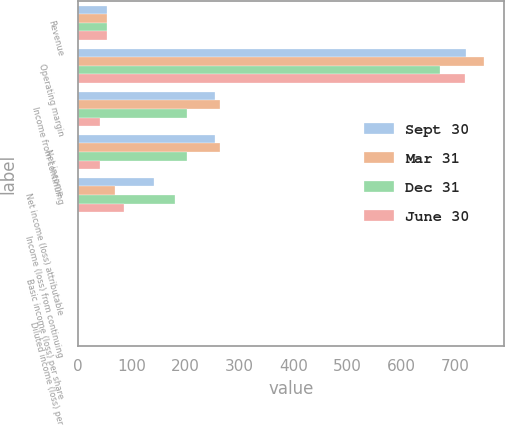Convert chart. <chart><loc_0><loc_0><loc_500><loc_500><stacked_bar_chart><ecel><fcel>Revenue<fcel>Operating margin<fcel>Income from continuing<fcel>Net income<fcel>Net income (loss) attributable<fcel>Income (loss) from continuing<fcel>Basic income (loss) per share<fcel>Diluted income (loss) per<nl><fcel>Sept 30<fcel>55<fcel>721<fcel>254<fcel>254<fcel>142<fcel>0.2<fcel>0.2<fcel>0.2<nl><fcel>Mar 31<fcel>55<fcel>754<fcel>264<fcel>264<fcel>69<fcel>0.1<fcel>0.1<fcel>0.1<nl><fcel>Dec 31<fcel>55<fcel>673<fcel>203<fcel>203<fcel>180<fcel>0.27<fcel>0.27<fcel>0.26<nl><fcel>June 30<fcel>55<fcel>718<fcel>41<fcel>41<fcel>85<fcel>0.13<fcel>0.13<fcel>0.13<nl></chart> 